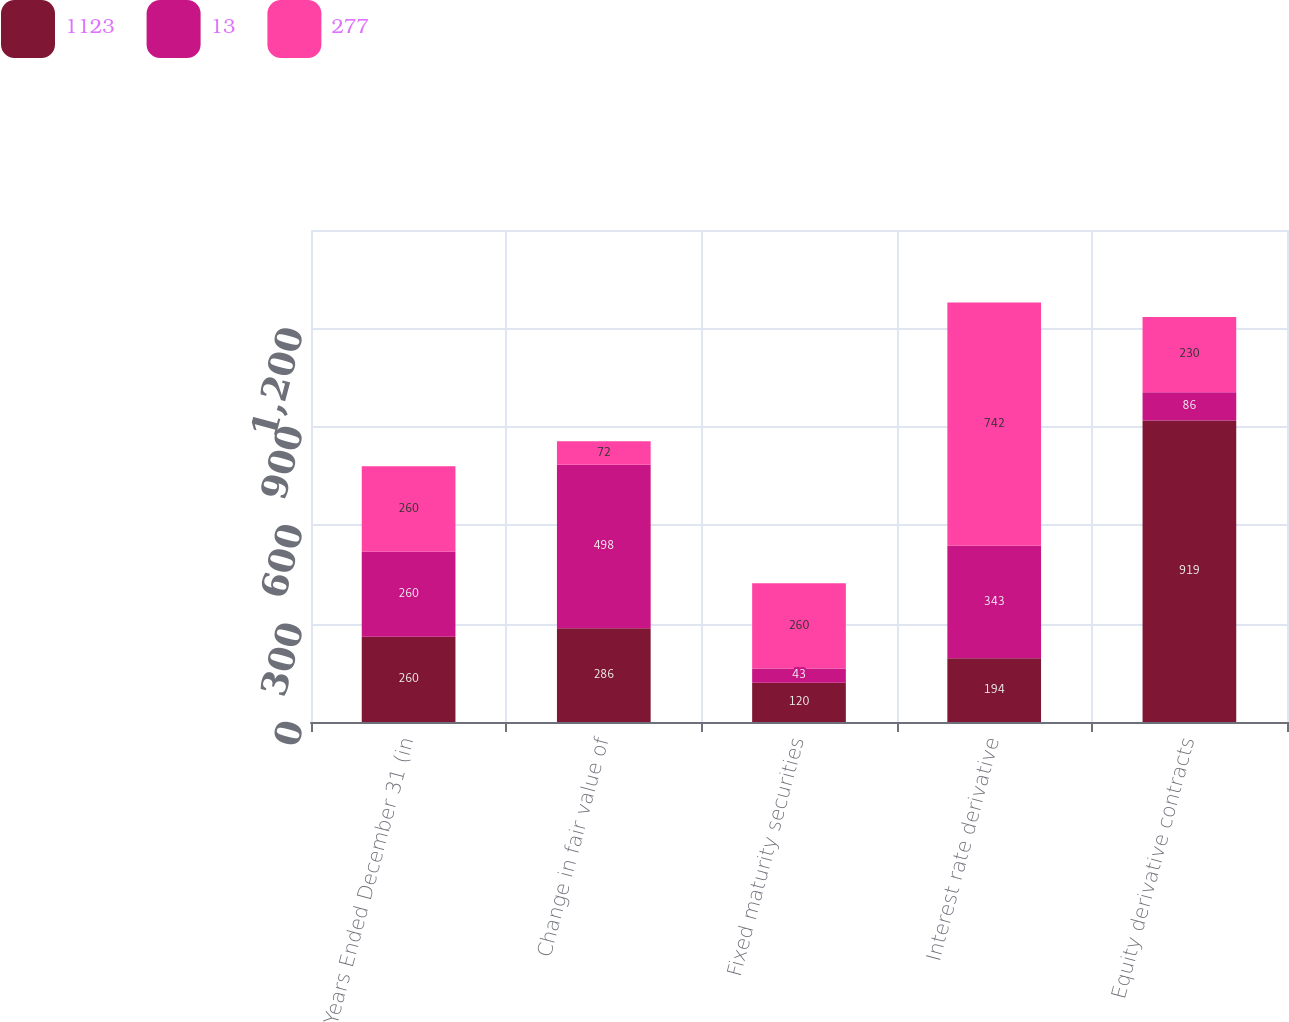Convert chart to OTSL. <chart><loc_0><loc_0><loc_500><loc_500><stacked_bar_chart><ecel><fcel>Years Ended December 31 (in<fcel>Change in fair value of<fcel>Fixed maturity securities<fcel>Interest rate derivative<fcel>Equity derivative contracts<nl><fcel>1123<fcel>260<fcel>286<fcel>120<fcel>194<fcel>919<nl><fcel>13<fcel>260<fcel>498<fcel>43<fcel>343<fcel>86<nl><fcel>277<fcel>260<fcel>72<fcel>260<fcel>742<fcel>230<nl></chart> 